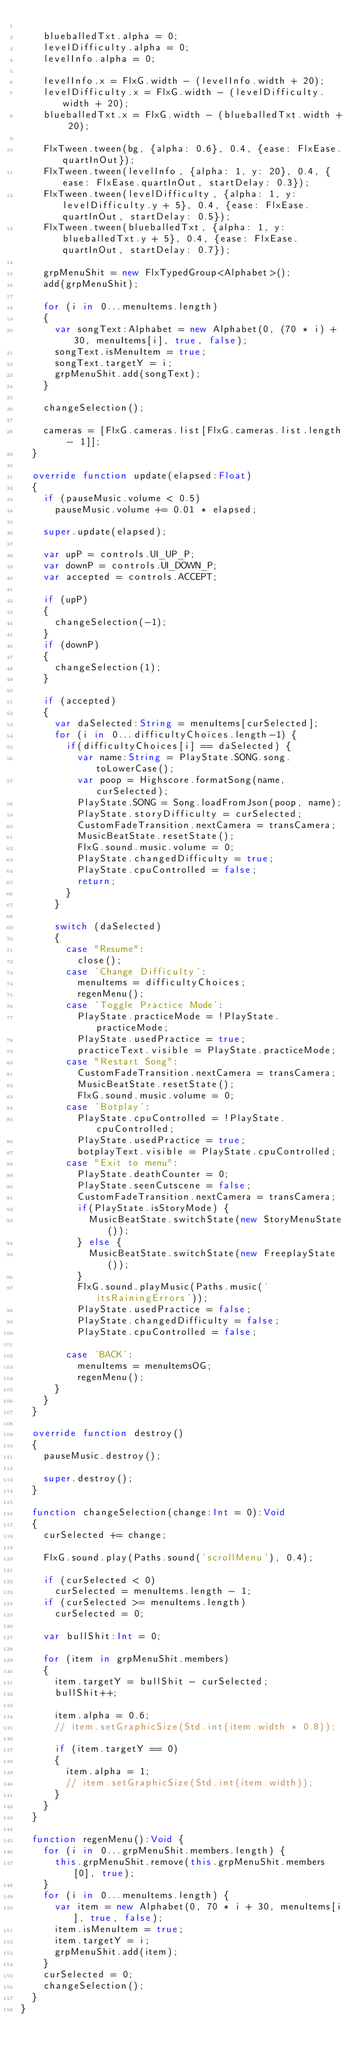<code> <loc_0><loc_0><loc_500><loc_500><_Haxe_>
		blueballedTxt.alpha = 0;
		levelDifficulty.alpha = 0;
		levelInfo.alpha = 0;

		levelInfo.x = FlxG.width - (levelInfo.width + 20);
		levelDifficulty.x = FlxG.width - (levelDifficulty.width + 20);
		blueballedTxt.x = FlxG.width - (blueballedTxt.width + 20);

		FlxTween.tween(bg, {alpha: 0.6}, 0.4, {ease: FlxEase.quartInOut});
		FlxTween.tween(levelInfo, {alpha: 1, y: 20}, 0.4, {ease: FlxEase.quartInOut, startDelay: 0.3});
		FlxTween.tween(levelDifficulty, {alpha: 1, y: levelDifficulty.y + 5}, 0.4, {ease: FlxEase.quartInOut, startDelay: 0.5});
		FlxTween.tween(blueballedTxt, {alpha: 1, y: blueballedTxt.y + 5}, 0.4, {ease: FlxEase.quartInOut, startDelay: 0.7});

		grpMenuShit = new FlxTypedGroup<Alphabet>();
		add(grpMenuShit);

		for (i in 0...menuItems.length)
		{
			var songText:Alphabet = new Alphabet(0, (70 * i) + 30, menuItems[i], true, false);
			songText.isMenuItem = true;
			songText.targetY = i;
			grpMenuShit.add(songText);
		}

		changeSelection();

		cameras = [FlxG.cameras.list[FlxG.cameras.list.length - 1]];
	}

	override function update(elapsed:Float)
	{
		if (pauseMusic.volume < 0.5)
			pauseMusic.volume += 0.01 * elapsed;

		super.update(elapsed);

		var upP = controls.UI_UP_P;
		var downP = controls.UI_DOWN_P;
		var accepted = controls.ACCEPT;

		if (upP)
		{
			changeSelection(-1);
		}
		if (downP)
		{
			changeSelection(1);
		}

		if (accepted)
		{
			var daSelected:String = menuItems[curSelected];
			for (i in 0...difficultyChoices.length-1) {
				if(difficultyChoices[i] == daSelected) {
					var name:String = PlayState.SONG.song.toLowerCase();
					var poop = Highscore.formatSong(name, curSelected);
					PlayState.SONG = Song.loadFromJson(poop, name);
					PlayState.storyDifficulty = curSelected;
					CustomFadeTransition.nextCamera = transCamera;
					MusicBeatState.resetState();
					FlxG.sound.music.volume = 0;
					PlayState.changedDifficulty = true;
					PlayState.cpuControlled = false;
					return;
				}
			} 

			switch (daSelected)
			{
				case "Resume":
					close();
				case 'Change Difficulty':
					menuItems = difficultyChoices;
					regenMenu();
				case 'Toggle Practice Mode':
					PlayState.practiceMode = !PlayState.practiceMode;
					PlayState.usedPractice = true;
					practiceText.visible = PlayState.practiceMode;
				case "Restart Song":
					CustomFadeTransition.nextCamera = transCamera;
					MusicBeatState.resetState();
					FlxG.sound.music.volume = 0;
				case 'Botplay':
					PlayState.cpuControlled = !PlayState.cpuControlled;
					PlayState.usedPractice = true;
					botplayText.visible = PlayState.cpuControlled;
				case "Exit to menu":
					PlayState.deathCounter = 0;
					PlayState.seenCutscene = false;
					CustomFadeTransition.nextCamera = transCamera;
					if(PlayState.isStoryMode) {
						MusicBeatState.switchState(new StoryMenuState());
					} else {
						MusicBeatState.switchState(new FreeplayState());
					}
					FlxG.sound.playMusic(Paths.music('itsRainingErrors'));
					PlayState.usedPractice = false;
					PlayState.changedDifficulty = false;
					PlayState.cpuControlled = false;

				case 'BACK':
					menuItems = menuItemsOG;
					regenMenu();
			}
		}
	}

	override function destroy()
	{
		pauseMusic.destroy();

		super.destroy();
	}

	function changeSelection(change:Int = 0):Void
	{
		curSelected += change;

		FlxG.sound.play(Paths.sound('scrollMenu'), 0.4);

		if (curSelected < 0)
			curSelected = menuItems.length - 1;
		if (curSelected >= menuItems.length)
			curSelected = 0;

		var bullShit:Int = 0;

		for (item in grpMenuShit.members)
		{
			item.targetY = bullShit - curSelected;
			bullShit++;

			item.alpha = 0.6;
			// item.setGraphicSize(Std.int(item.width * 0.8));

			if (item.targetY == 0)
			{
				item.alpha = 1;
				// item.setGraphicSize(Std.int(item.width));
			}
		}
	}

	function regenMenu():Void {
		for (i in 0...grpMenuShit.members.length) {
			this.grpMenuShit.remove(this.grpMenuShit.members[0], true);
		}
		for (i in 0...menuItems.length) {
			var item = new Alphabet(0, 70 * i + 30, menuItems[i], true, false);
			item.isMenuItem = true;
			item.targetY = i;
			grpMenuShit.add(item);
		}
		curSelected = 0;
		changeSelection();
	}
}
</code> 